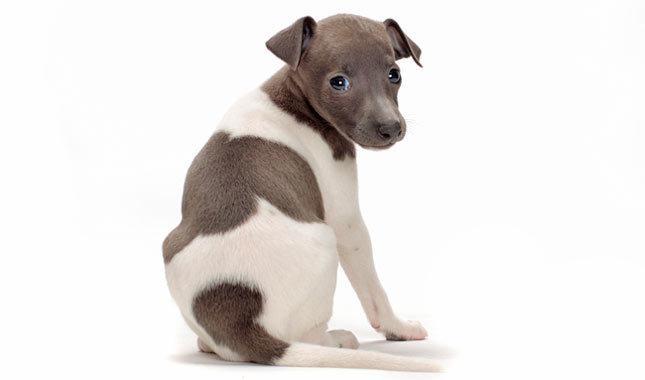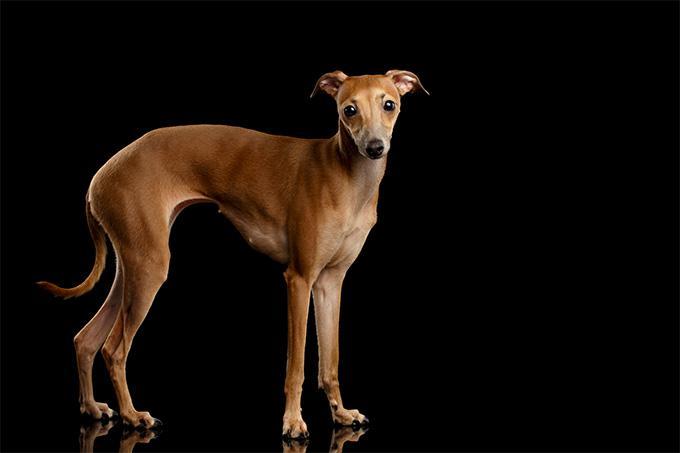The first image is the image on the left, the second image is the image on the right. Assess this claim about the two images: "An image shows a two-color dog sitting upright with its eyes on the camera.". Correct or not? Answer yes or no. Yes. The first image is the image on the left, the second image is the image on the right. Given the left and right images, does the statement "Exactly one of the dogs is lying down." hold true? Answer yes or no. No. 